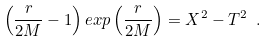<formula> <loc_0><loc_0><loc_500><loc_500>\left ( \frac { r } { 2 M } - 1 \right ) e x p \left ( \frac { r } { 2 M } \right ) = X ^ { 2 } - T ^ { 2 } \ .</formula> 